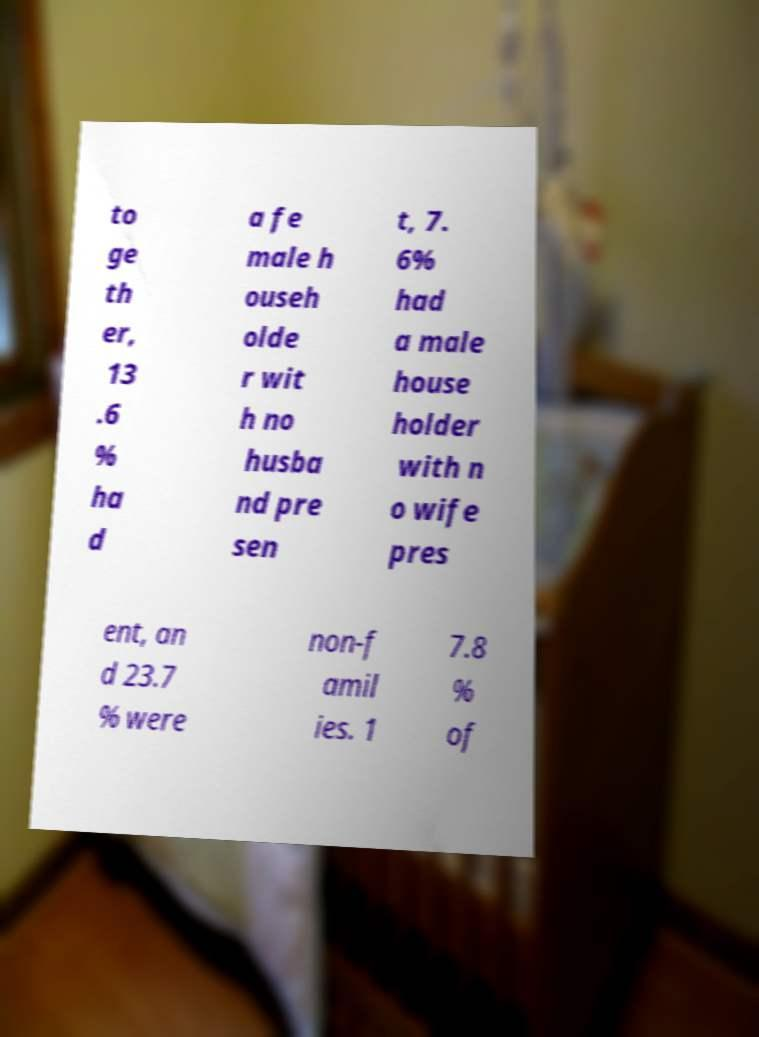There's text embedded in this image that I need extracted. Can you transcribe it verbatim? to ge th er, 13 .6 % ha d a fe male h ouseh olde r wit h no husba nd pre sen t, 7. 6% had a male house holder with n o wife pres ent, an d 23.7 % were non-f amil ies. 1 7.8 % of 